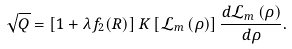<formula> <loc_0><loc_0><loc_500><loc_500>\sqrt { Q } = \left [ 1 + \lambda f _ { 2 } ( R ) \right ] K \left [ \mathcal { L } _ { m } \left ( \rho \right ) \right ] \frac { d \mathcal { L } _ { m } \left ( \rho \right ) } { d \rho } .</formula> 